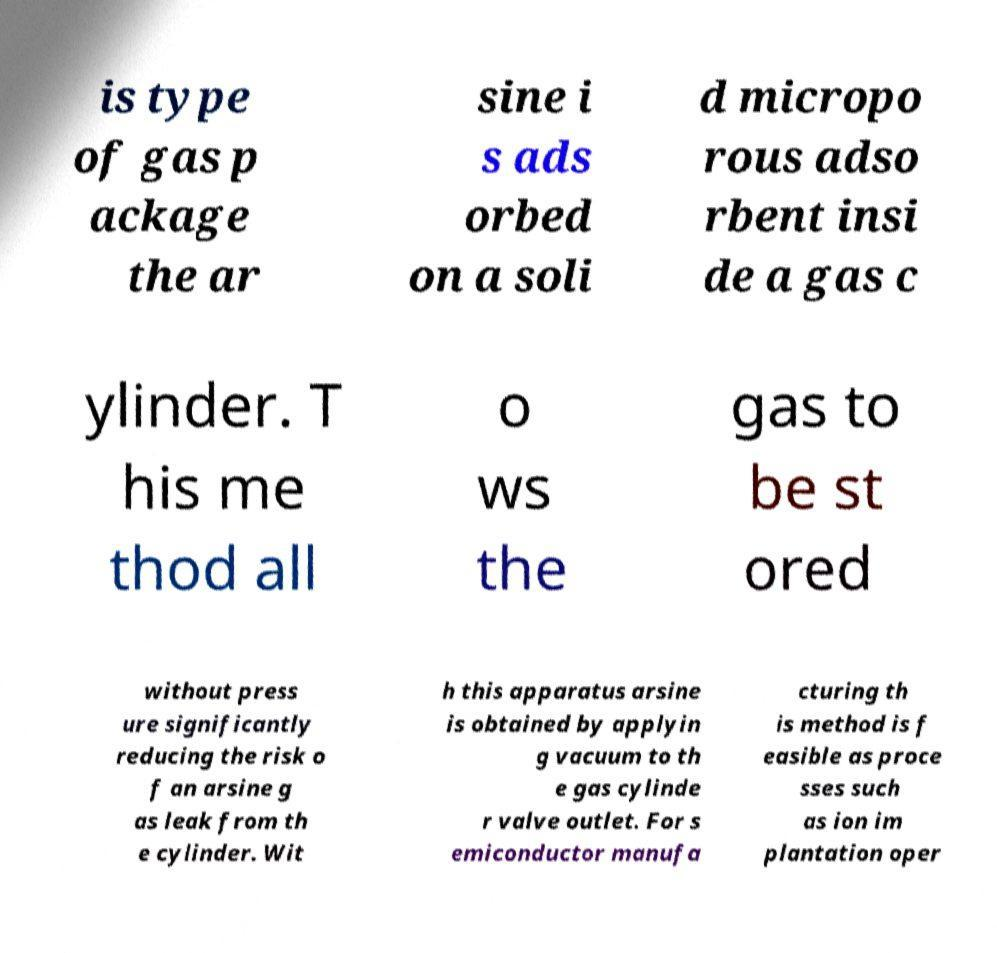There's text embedded in this image that I need extracted. Can you transcribe it verbatim? is type of gas p ackage the ar sine i s ads orbed on a soli d micropo rous adso rbent insi de a gas c ylinder. T his me thod all o ws the gas to be st ored without press ure significantly reducing the risk o f an arsine g as leak from th e cylinder. Wit h this apparatus arsine is obtained by applyin g vacuum to th e gas cylinde r valve outlet. For s emiconductor manufa cturing th is method is f easible as proce sses such as ion im plantation oper 